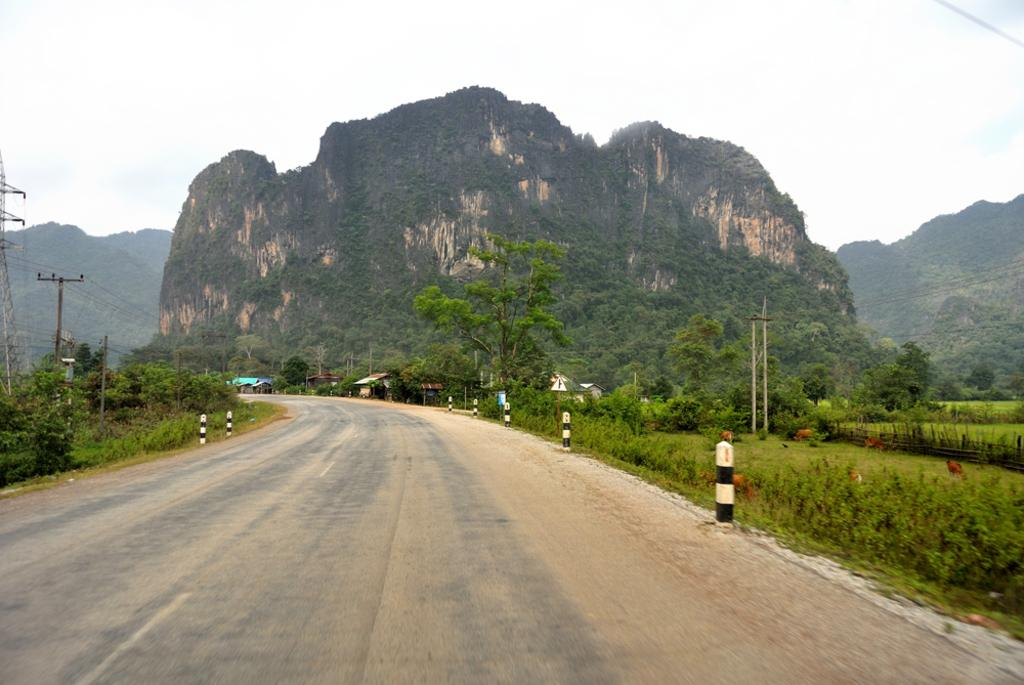What is the main feature in the middle of the picture? There is a road in the middle of the picture. What can be seen on either side of the road? Plants and trees are present on either side of the road. What is visible in the background of the image? Hills and the sky are visible in the background of the image. Where is the sofa located in the image? There is no sofa present in the image. What type of vegetable can be seen growing on the hills in the background? There are no vegetables visible in the image; only hills and the sky are present in the background. 